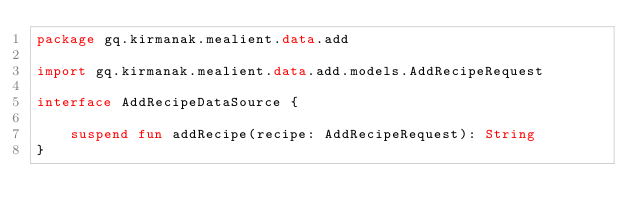<code> <loc_0><loc_0><loc_500><loc_500><_Kotlin_>package gq.kirmanak.mealient.data.add

import gq.kirmanak.mealient.data.add.models.AddRecipeRequest

interface AddRecipeDataSource {

    suspend fun addRecipe(recipe: AddRecipeRequest): String
}</code> 